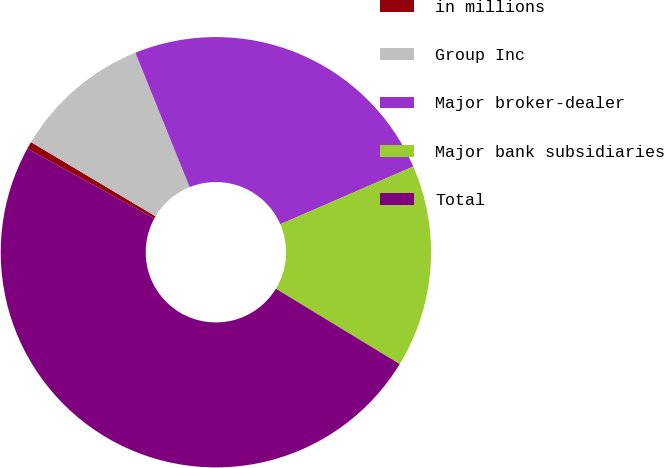Convert chart to OTSL. <chart><loc_0><loc_0><loc_500><loc_500><pie_chart><fcel>in millions<fcel>Group Inc<fcel>Major broker-dealer<fcel>Major bank subsidiaries<fcel>Total<nl><fcel>0.55%<fcel>10.35%<fcel>24.58%<fcel>15.22%<fcel>49.3%<nl></chart> 